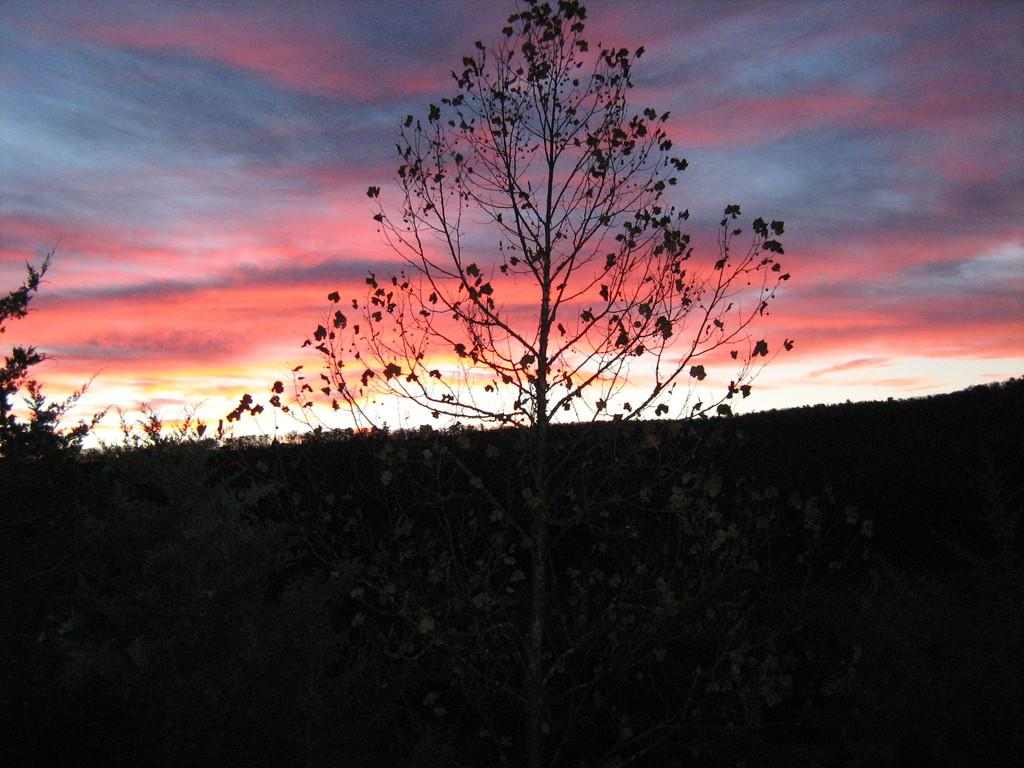What is the main subject in the center of the image? There is a tree in the center of the image. What type of vegetation can be seen at the bottom side of the image? There is greenery at the bottom side of the image. What is visible at the top side of the image? There is sky visible at the top side of the image. What color is the vest worn by the wren in the image? There is no wren or vest present in the image. 